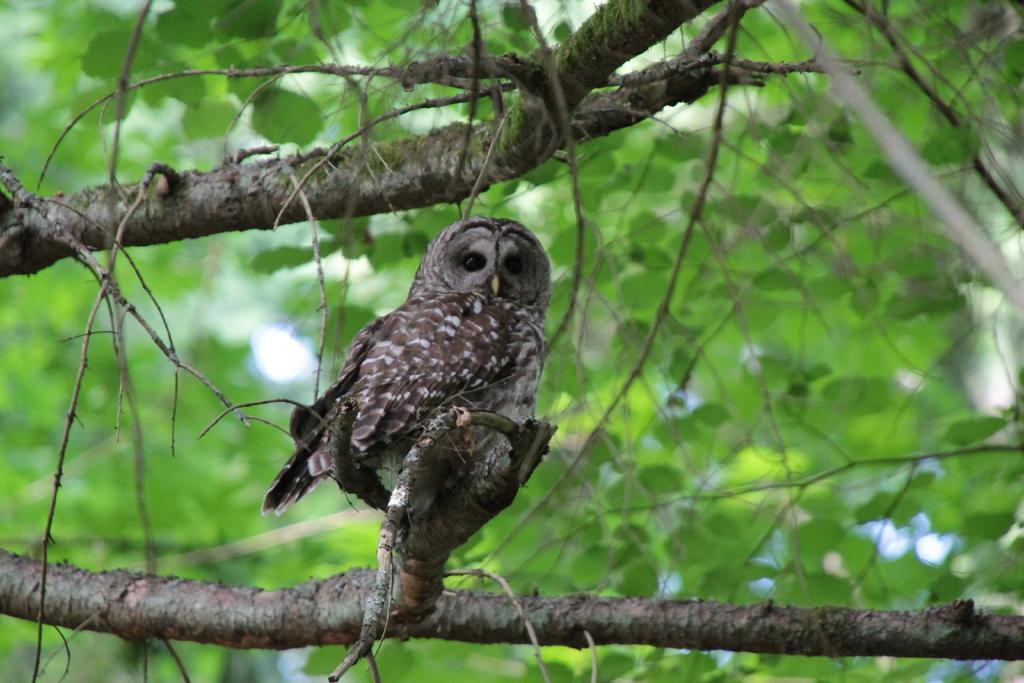Please provide a concise description of this image. In the picture we can see a owl sitting on the tree behind it we can see a leaves of the tree. 